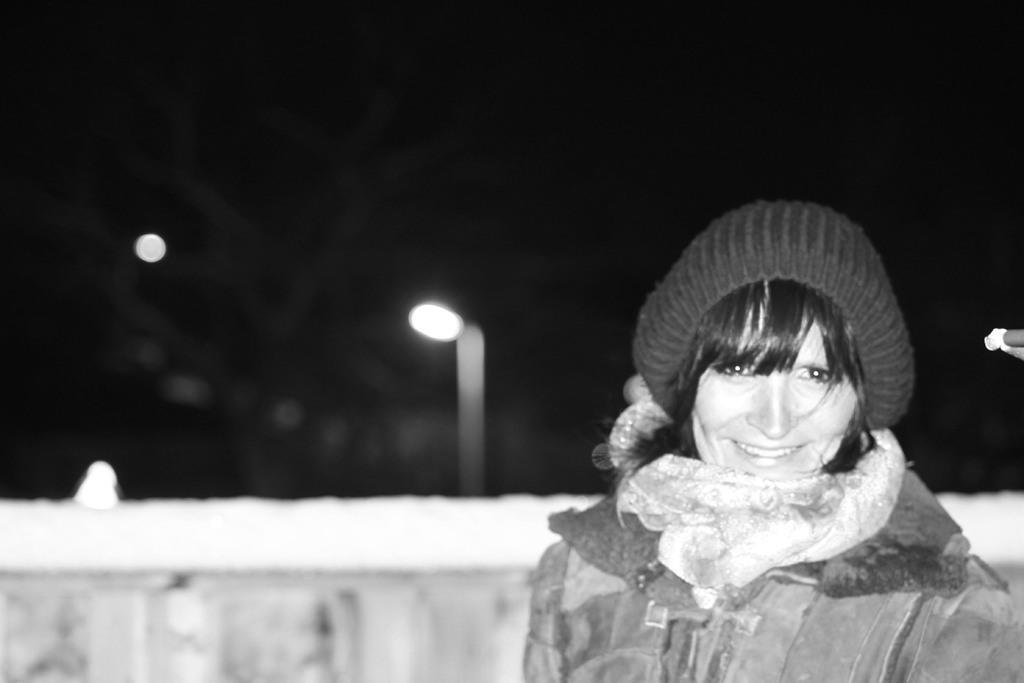Please provide a concise description of this image. This is a black and white pic. On the right there is a woman and and she is smiling and there is a cap on her head. In the background the image is blur but there are lights and other objects. 